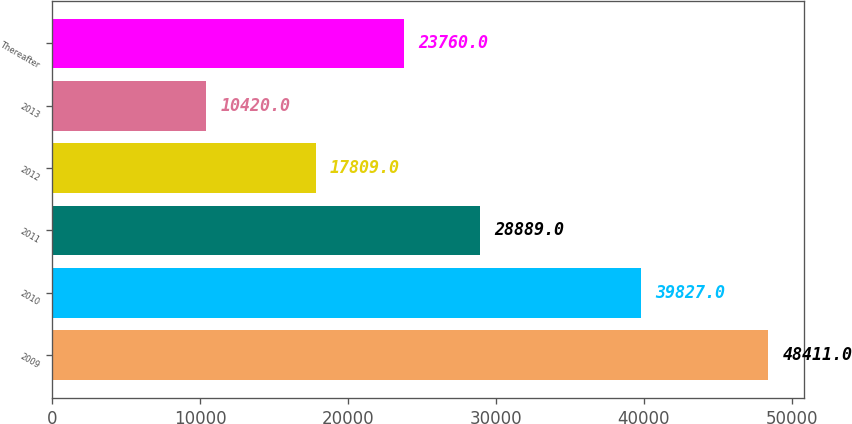Convert chart. <chart><loc_0><loc_0><loc_500><loc_500><bar_chart><fcel>2009<fcel>2010<fcel>2011<fcel>2012<fcel>2013<fcel>Thereafter<nl><fcel>48411<fcel>39827<fcel>28889<fcel>17809<fcel>10420<fcel>23760<nl></chart> 